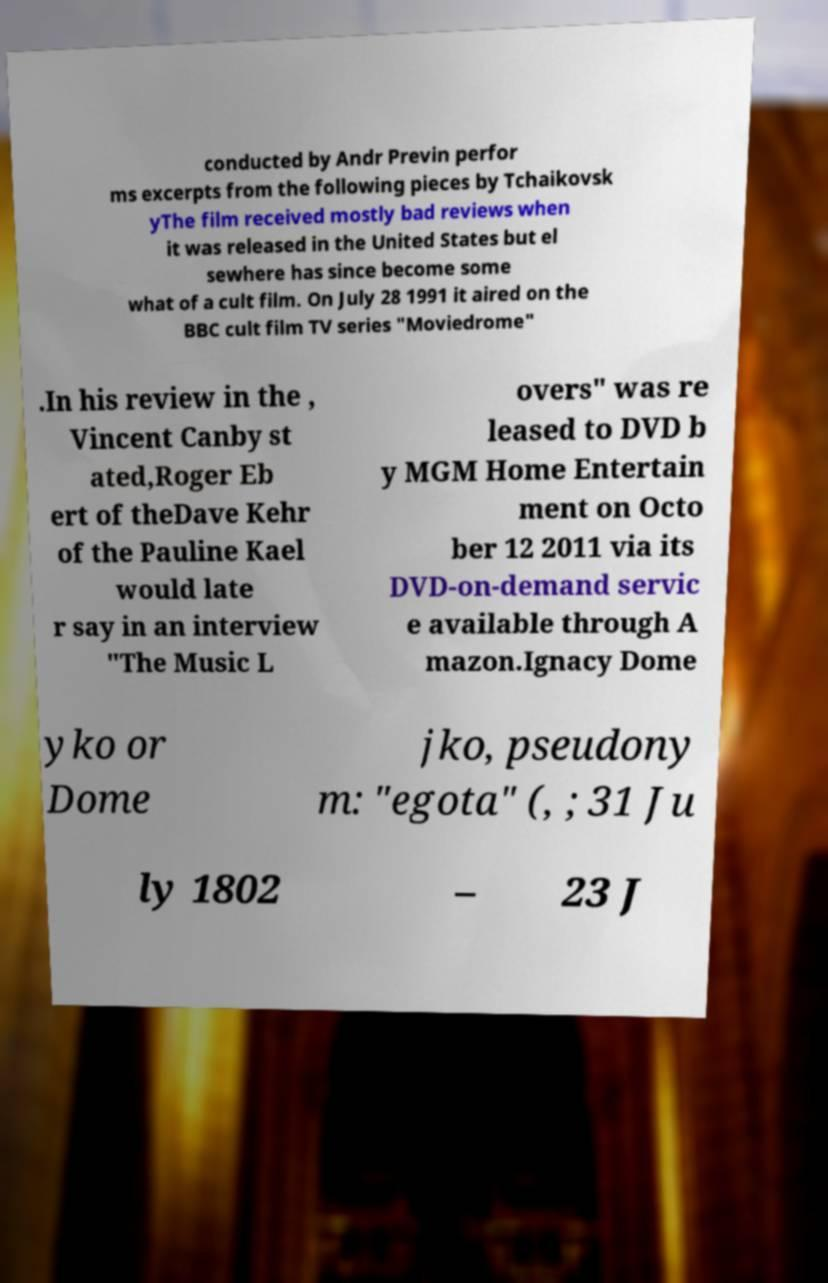Please read and relay the text visible in this image. What does it say? conducted by Andr Previn perfor ms excerpts from the following pieces by Tchaikovsk yThe film received mostly bad reviews when it was released in the United States but el sewhere has since become some what of a cult film. On July 28 1991 it aired on the BBC cult film TV series "Moviedrome" .In his review in the , Vincent Canby st ated,Roger Eb ert of theDave Kehr of the Pauline Kael would late r say in an interview "The Music L overs" was re leased to DVD b y MGM Home Entertain ment on Octo ber 12 2011 via its DVD-on-demand servic e available through A mazon.Ignacy Dome yko or Dome jko, pseudony m: "egota" (, ; 31 Ju ly 1802 – 23 J 